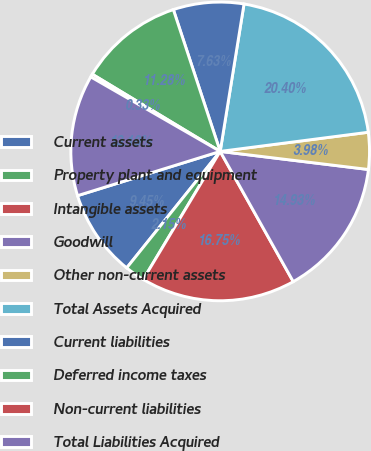Convert chart. <chart><loc_0><loc_0><loc_500><loc_500><pie_chart><fcel>Current assets<fcel>Property plant and equipment<fcel>Intangible assets<fcel>Goodwill<fcel>Other non-current assets<fcel>Total Assets Acquired<fcel>Current liabilities<fcel>Deferred income taxes<fcel>Non-current liabilities<fcel>Total Liabilities Acquired<nl><fcel>9.45%<fcel>2.15%<fcel>16.75%<fcel>14.93%<fcel>3.98%<fcel>20.4%<fcel>7.63%<fcel>11.28%<fcel>0.33%<fcel>13.1%<nl></chart> 